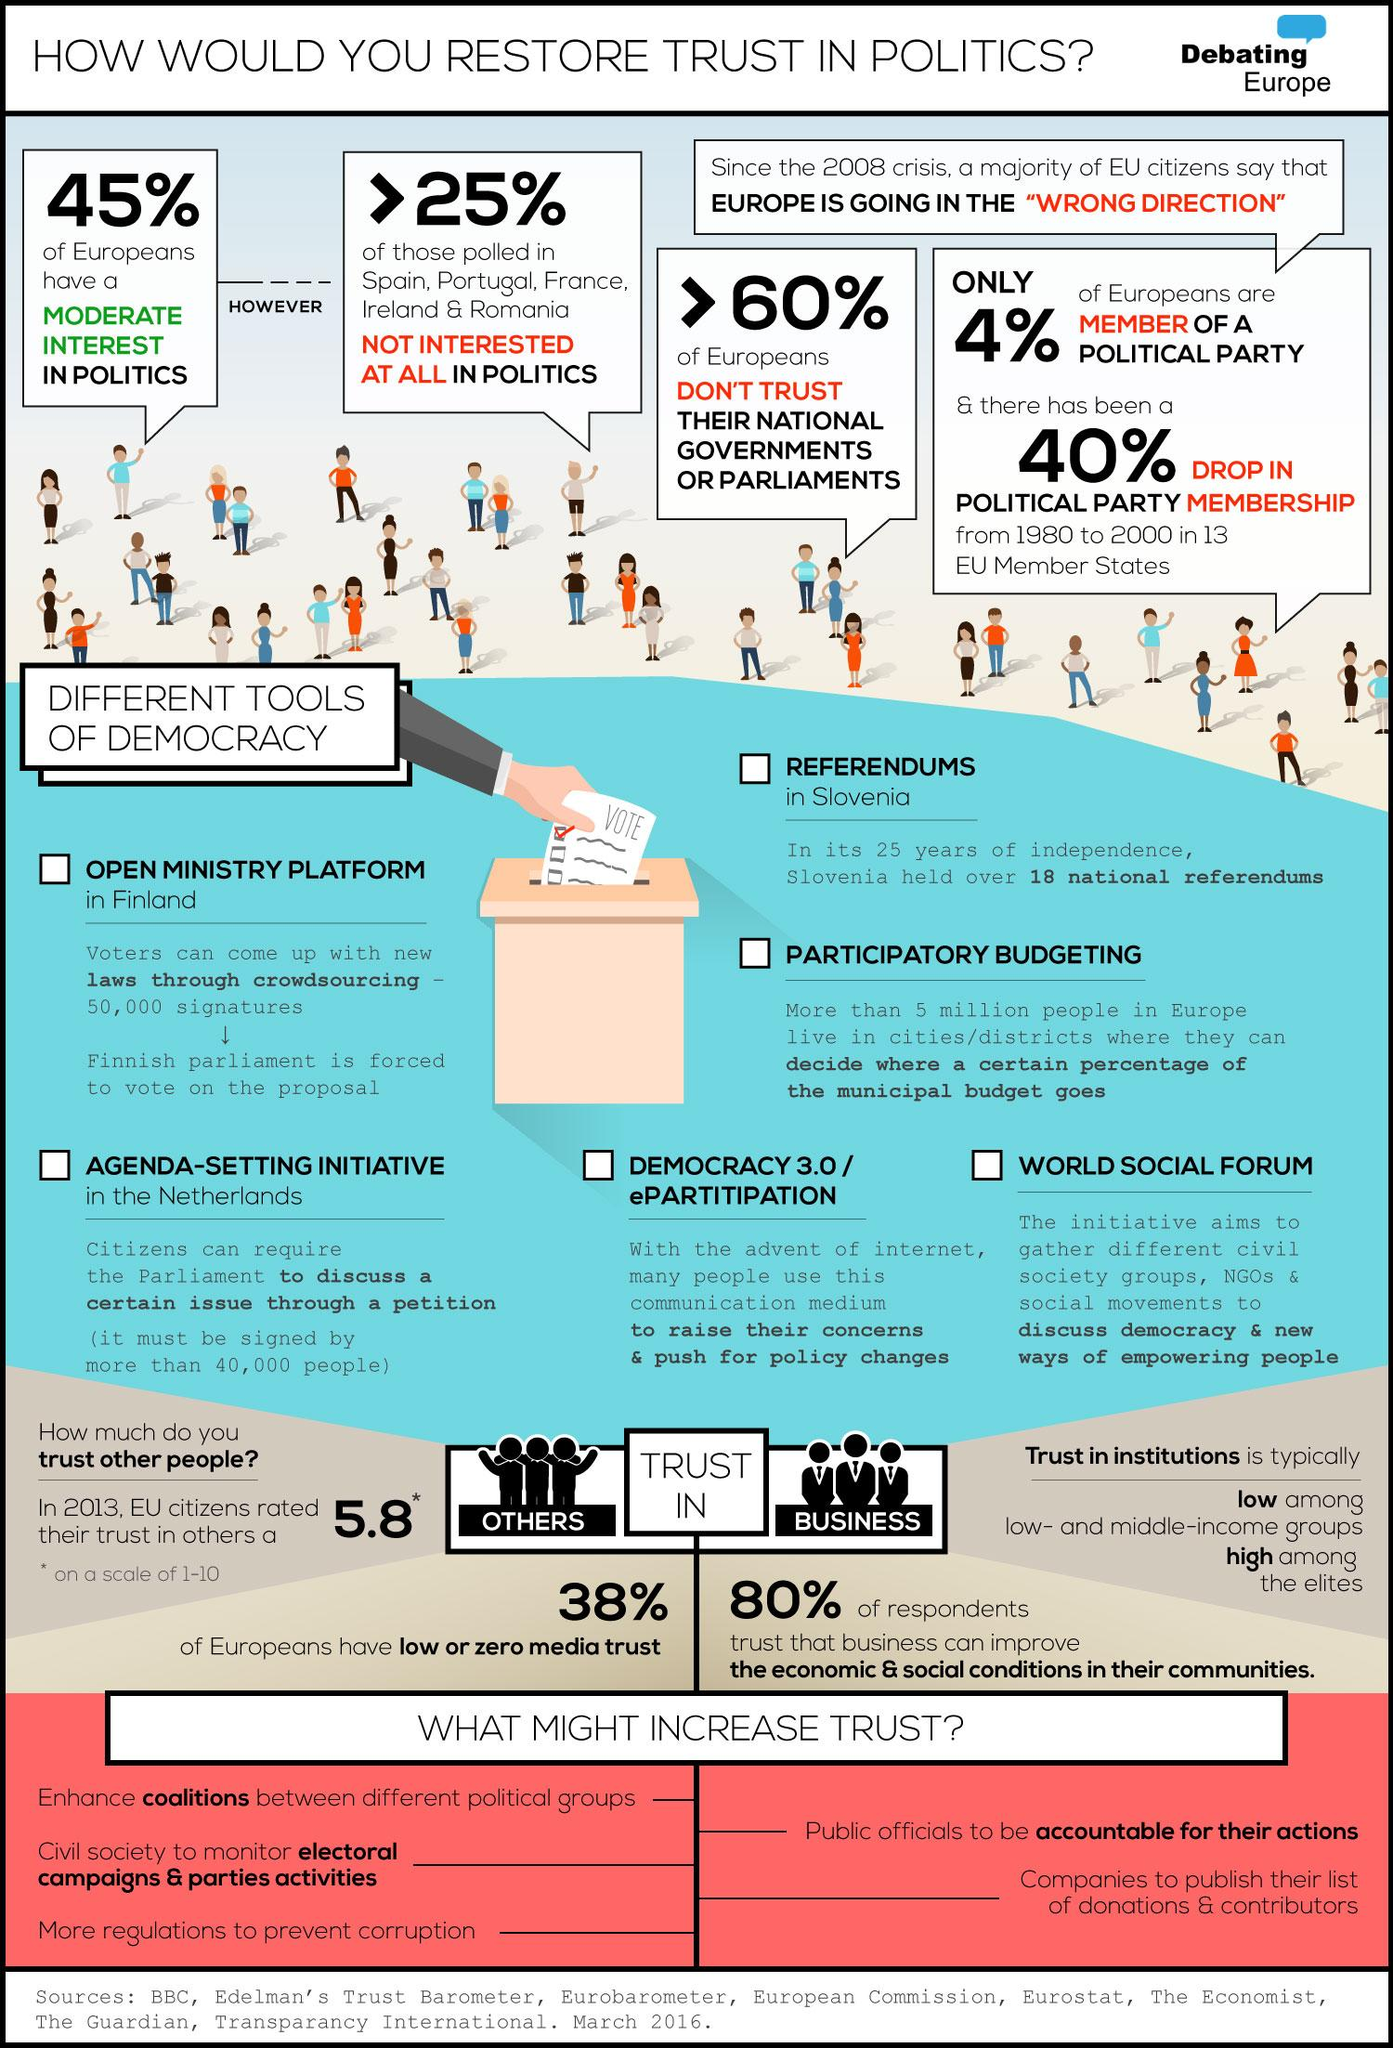Indicate a few pertinent items in this graphic. The use of the internet is employed by individuals to raise concerns and advocate for policy modifications. A significant percentage of people in some EU countries are not particularly interested in politics, with the figure exceeding 25%. A proposal must be signed by at least 50,000 individuals in order to be considered for a vote in the Finnish Parliament. According to a recent survey, 45% of Europeans are moderately interested in politics. The World Social Forum is a platform where various groups gather to discuss democracy and ways to empower people. 